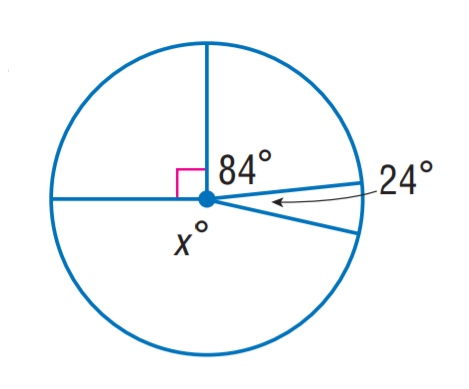Answer the mathemtical geometry problem and directly provide the correct option letter.
Question: Find x.
Choices: A: 96 B: 156 C: 162 D: 174 C 